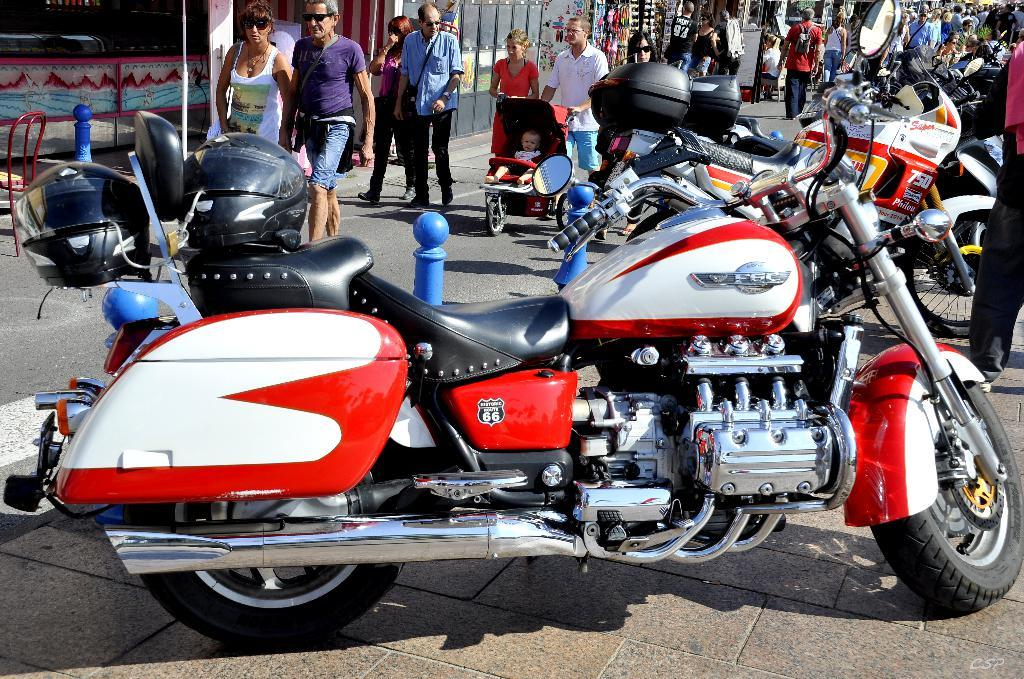<image>
Share a concise interpretation of the image provided. The F6C can be driven along the Route 66. 